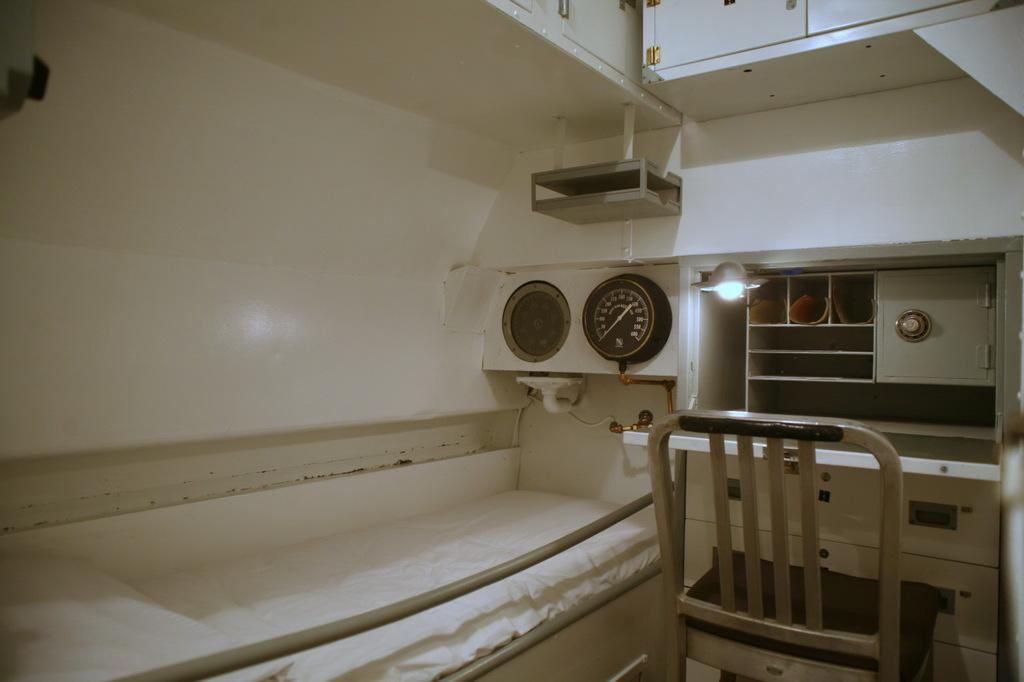What type of space is depicted in the image? The image shows an inner view of a room. What furniture is present in the room? There is a bed with a pillow and chairs in the room. What device is on the wall in the room? There is a dial on the wall. What source of light is in the room? There is a lamp in the room. What surrounds the space shown in the image? The room has walls. Can you see any birds or goldfish in the room? No, there are no birds or goldfish present in the room. Is there any indication of a fight taking place in the room? No, there is no indication of a fight or any conflict in the room. 